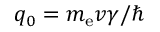<formula> <loc_0><loc_0><loc_500><loc_500>q _ { 0 } = m _ { e } v \gamma / \hbar</formula> 